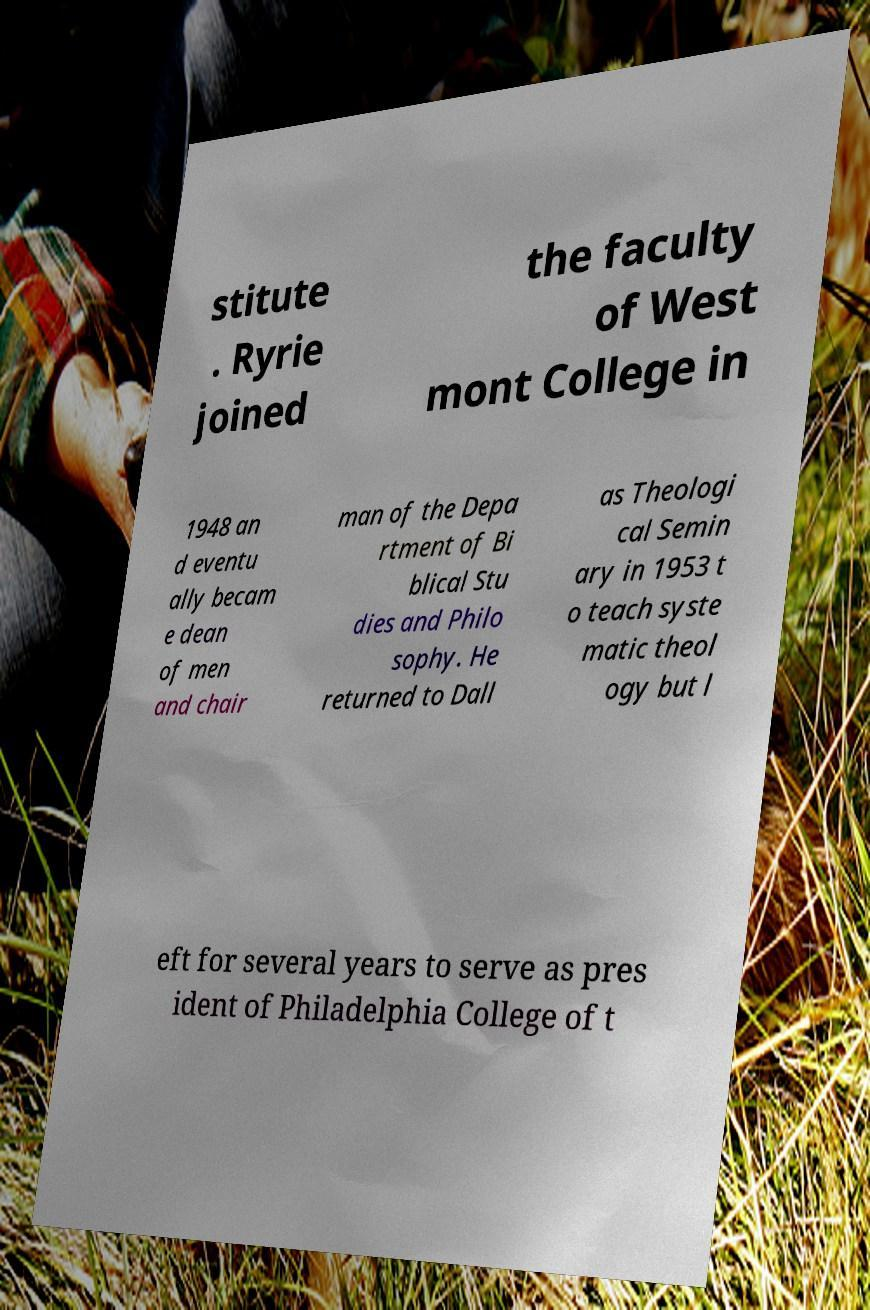I need the written content from this picture converted into text. Can you do that? stitute . Ryrie joined the faculty of West mont College in 1948 an d eventu ally becam e dean of men and chair man of the Depa rtment of Bi blical Stu dies and Philo sophy. He returned to Dall as Theologi cal Semin ary in 1953 t o teach syste matic theol ogy but l eft for several years to serve as pres ident of Philadelphia College of t 